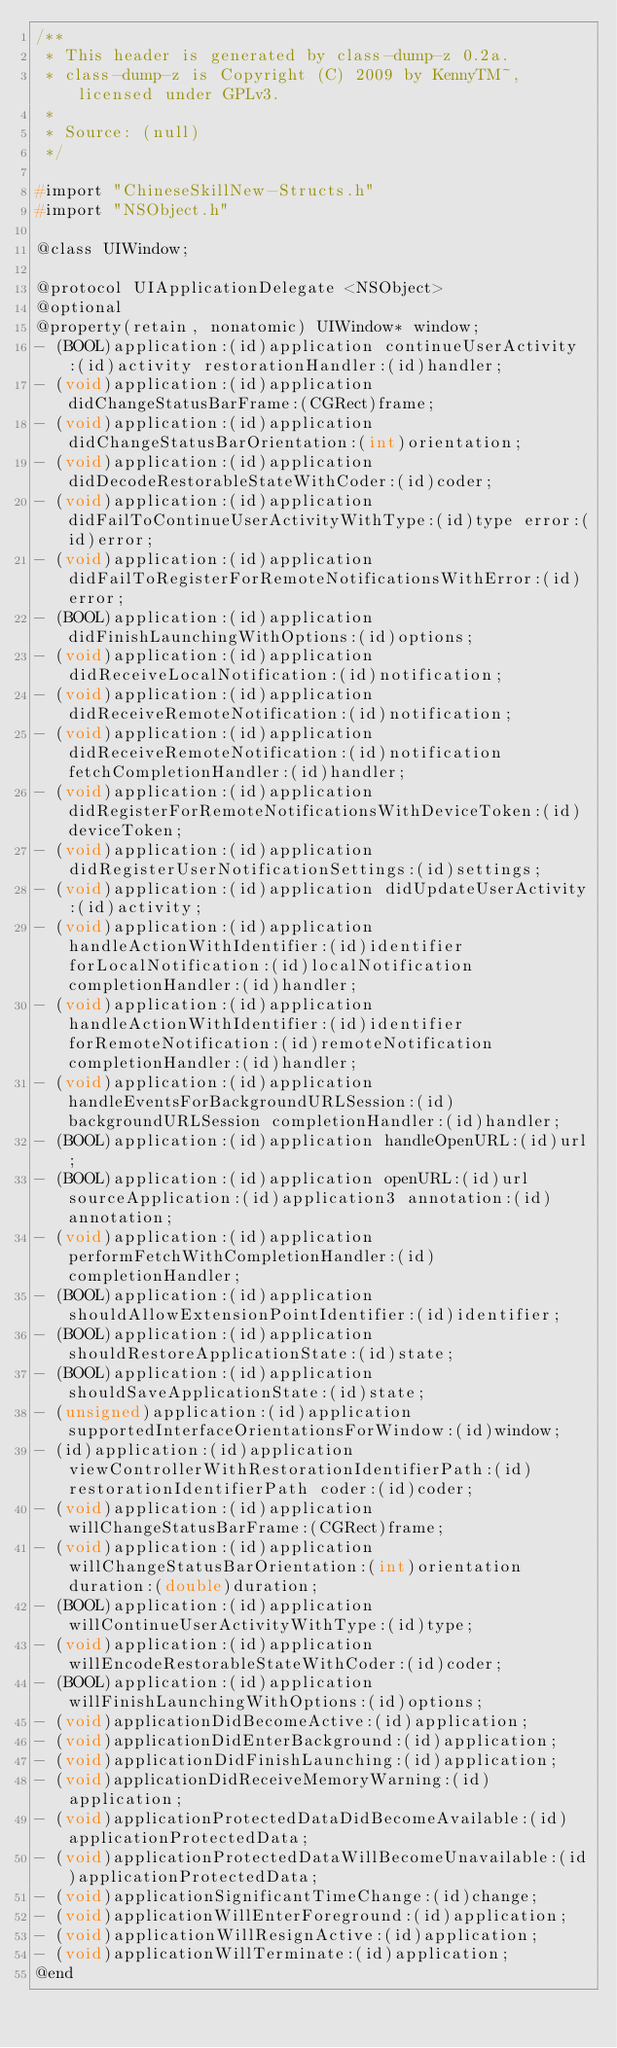Convert code to text. <code><loc_0><loc_0><loc_500><loc_500><_C_>/**
 * This header is generated by class-dump-z 0.2a.
 * class-dump-z is Copyright (C) 2009 by KennyTM~, licensed under GPLv3.
 *
 * Source: (null)
 */

#import "ChineseSkillNew-Structs.h"
#import "NSObject.h"

@class UIWindow;

@protocol UIApplicationDelegate <NSObject>
@optional
@property(retain, nonatomic) UIWindow* window;
- (BOOL)application:(id)application continueUserActivity:(id)activity restorationHandler:(id)handler;
- (void)application:(id)application didChangeStatusBarFrame:(CGRect)frame;
- (void)application:(id)application didChangeStatusBarOrientation:(int)orientation;
- (void)application:(id)application didDecodeRestorableStateWithCoder:(id)coder;
- (void)application:(id)application didFailToContinueUserActivityWithType:(id)type error:(id)error;
- (void)application:(id)application didFailToRegisterForRemoteNotificationsWithError:(id)error;
- (BOOL)application:(id)application didFinishLaunchingWithOptions:(id)options;
- (void)application:(id)application didReceiveLocalNotification:(id)notification;
- (void)application:(id)application didReceiveRemoteNotification:(id)notification;
- (void)application:(id)application didReceiveRemoteNotification:(id)notification fetchCompletionHandler:(id)handler;
- (void)application:(id)application didRegisterForRemoteNotificationsWithDeviceToken:(id)deviceToken;
- (void)application:(id)application didRegisterUserNotificationSettings:(id)settings;
- (void)application:(id)application didUpdateUserActivity:(id)activity;
- (void)application:(id)application handleActionWithIdentifier:(id)identifier forLocalNotification:(id)localNotification completionHandler:(id)handler;
- (void)application:(id)application handleActionWithIdentifier:(id)identifier forRemoteNotification:(id)remoteNotification completionHandler:(id)handler;
- (void)application:(id)application handleEventsForBackgroundURLSession:(id)backgroundURLSession completionHandler:(id)handler;
- (BOOL)application:(id)application handleOpenURL:(id)url;
- (BOOL)application:(id)application openURL:(id)url sourceApplication:(id)application3 annotation:(id)annotation;
- (void)application:(id)application performFetchWithCompletionHandler:(id)completionHandler;
- (BOOL)application:(id)application shouldAllowExtensionPointIdentifier:(id)identifier;
- (BOOL)application:(id)application shouldRestoreApplicationState:(id)state;
- (BOOL)application:(id)application shouldSaveApplicationState:(id)state;
- (unsigned)application:(id)application supportedInterfaceOrientationsForWindow:(id)window;
- (id)application:(id)application viewControllerWithRestorationIdentifierPath:(id)restorationIdentifierPath coder:(id)coder;
- (void)application:(id)application willChangeStatusBarFrame:(CGRect)frame;
- (void)application:(id)application willChangeStatusBarOrientation:(int)orientation duration:(double)duration;
- (BOOL)application:(id)application willContinueUserActivityWithType:(id)type;
- (void)application:(id)application willEncodeRestorableStateWithCoder:(id)coder;
- (BOOL)application:(id)application willFinishLaunchingWithOptions:(id)options;
- (void)applicationDidBecomeActive:(id)application;
- (void)applicationDidEnterBackground:(id)application;
- (void)applicationDidFinishLaunching:(id)application;
- (void)applicationDidReceiveMemoryWarning:(id)application;
- (void)applicationProtectedDataDidBecomeAvailable:(id)applicationProtectedData;
- (void)applicationProtectedDataWillBecomeUnavailable:(id)applicationProtectedData;
- (void)applicationSignificantTimeChange:(id)change;
- (void)applicationWillEnterForeground:(id)application;
- (void)applicationWillResignActive:(id)application;
- (void)applicationWillTerminate:(id)application;
@end

</code> 